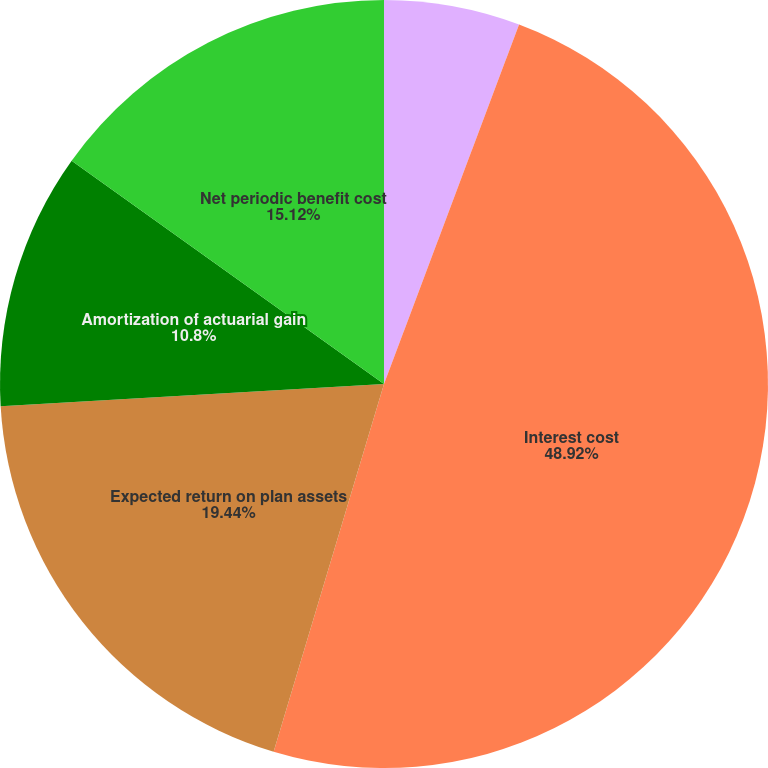Convert chart. <chart><loc_0><loc_0><loc_500><loc_500><pie_chart><fcel>Service cost<fcel>Interest cost<fcel>Expected return on plan assets<fcel>Amortization of actuarial gain<fcel>Net periodic benefit cost<nl><fcel>5.72%<fcel>48.92%<fcel>19.44%<fcel>10.8%<fcel>15.12%<nl></chart> 